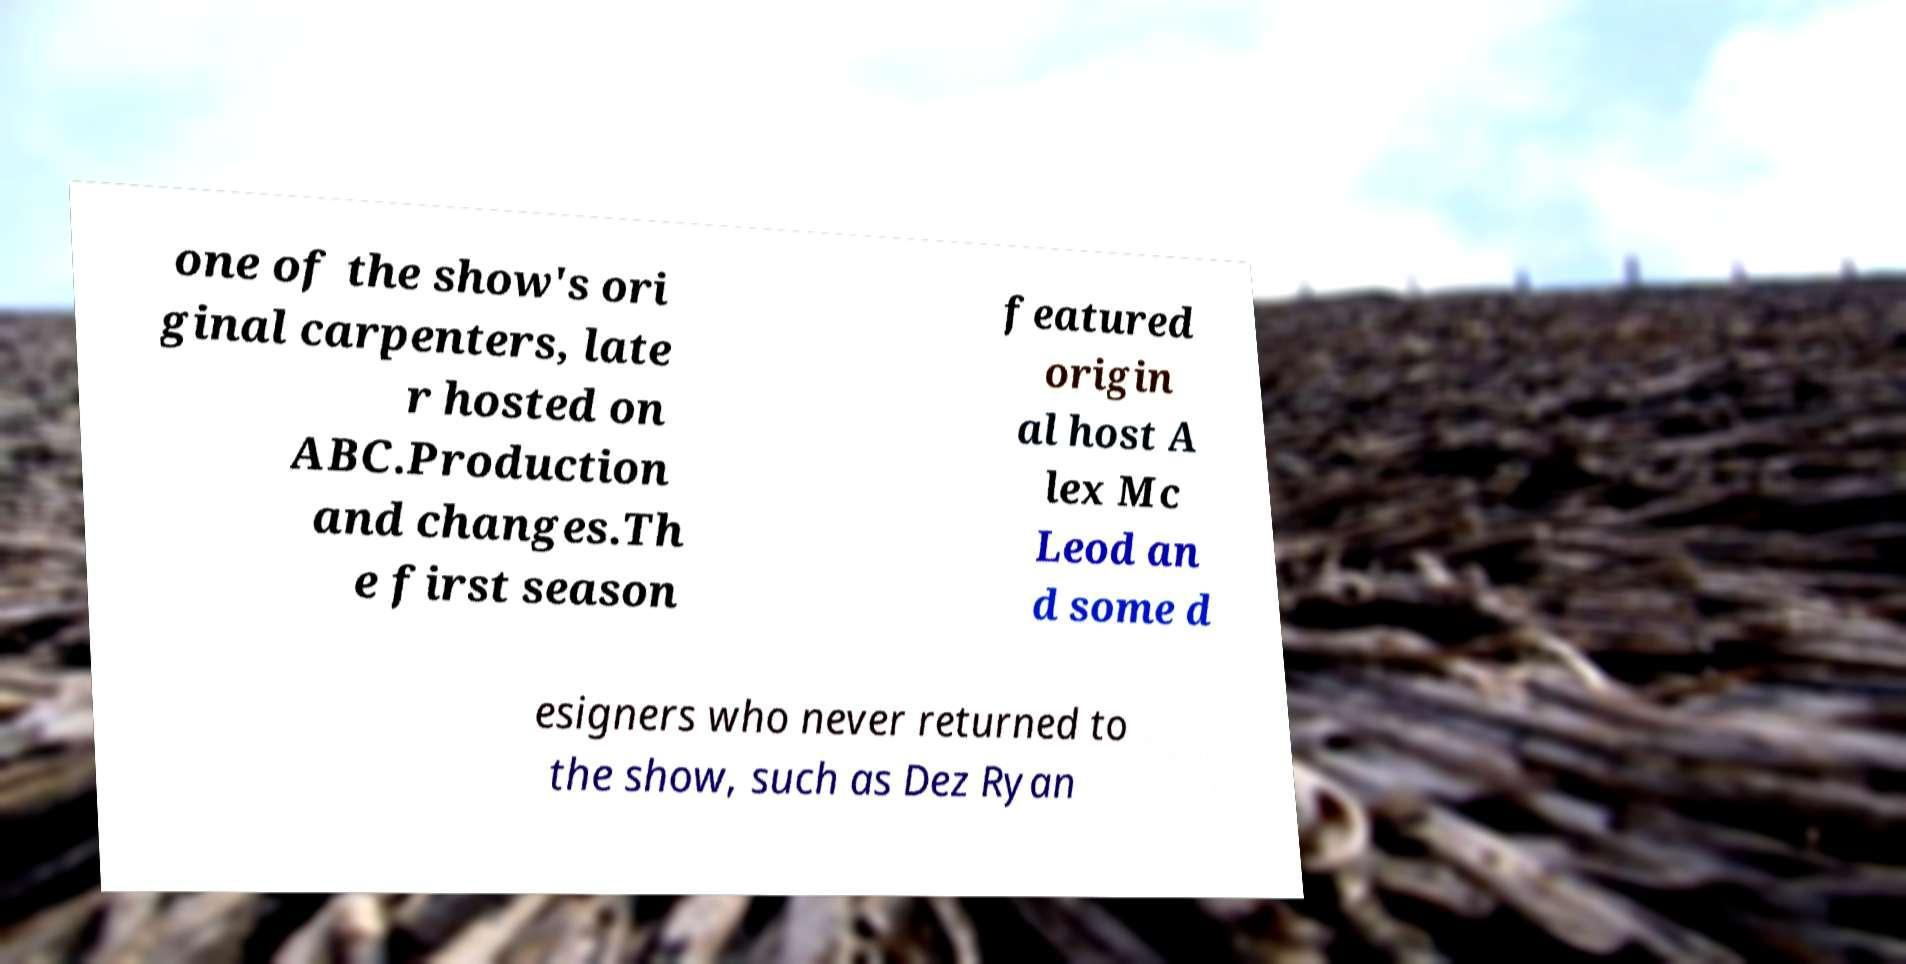Could you assist in decoding the text presented in this image and type it out clearly? one of the show's ori ginal carpenters, late r hosted on ABC.Production and changes.Th e first season featured origin al host A lex Mc Leod an d some d esigners who never returned to the show, such as Dez Ryan 